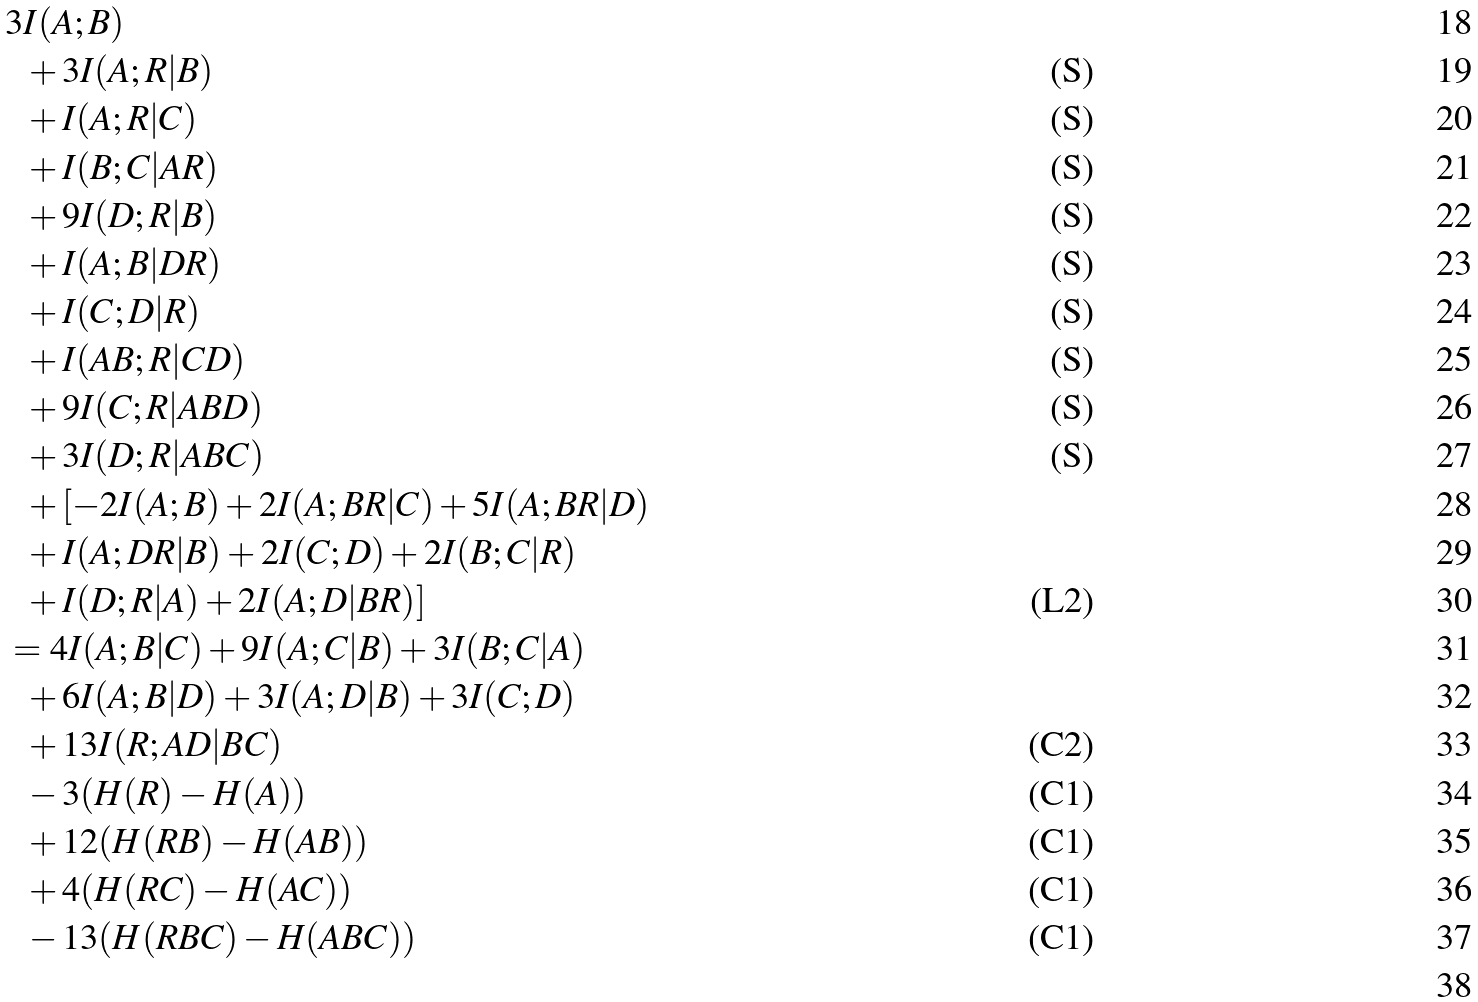<formula> <loc_0><loc_0><loc_500><loc_500>& 3 I ( A ; B ) & \\ & \ \ + 3 I ( A ; R | B ) & \text {(S)} \\ & \ \ + I ( A ; R | C ) & \text {(S)} \\ & \ \ + I ( B ; C | A R ) & \text {(S)} \\ & \ \ + 9 I ( D ; R | B ) & \text {(S)} \\ & \ \ + I ( A ; B | D R ) & \text {(S)} \\ & \ \ + I ( C ; D | R ) & \text {(S)} \\ & \ \ + I ( A B ; R | C D ) & \text {(S)} \\ & \ \ + 9 I ( C ; R | A B D ) & \text {(S)} \\ & \ \ + 3 I ( D ; R | A B C ) & \text {(S)} \\ & \ \ + [ - 2 I ( A ; B ) + 2 I ( A ; B R | C ) + 5 I ( A ; B R | D ) \\ & \ \ + I ( A ; D R | B ) + 2 I ( C ; D ) + 2 I ( B ; C | R ) \\ & \ \ + I ( D ; R | A ) + 2 I ( A ; D | B R ) ] & \text {(L2)} \\ & = 4 I ( A ; B | C ) + 9 I ( A ; C | B ) + 3 I ( B ; C | A ) \\ & \ \ + 6 I ( A ; B | D ) + 3 I ( A ; D | B ) + 3 I ( C ; D ) \\ & \ \ + 1 3 I ( R ; A D | B C ) & \text {(C2)} \\ & \ \ - 3 ( H ( R ) - H ( A ) ) & \text {(C1)} \\ & \ \ + 1 2 ( H ( R B ) - H ( A B ) ) & \text {(C1)} \\ & \ \ + 4 ( H ( R C ) - H ( A C ) ) & \text {(C1)} \\ & \ \ - 1 3 ( H ( R B C ) - H ( A B C ) ) & \text {(C1)} \\</formula> 